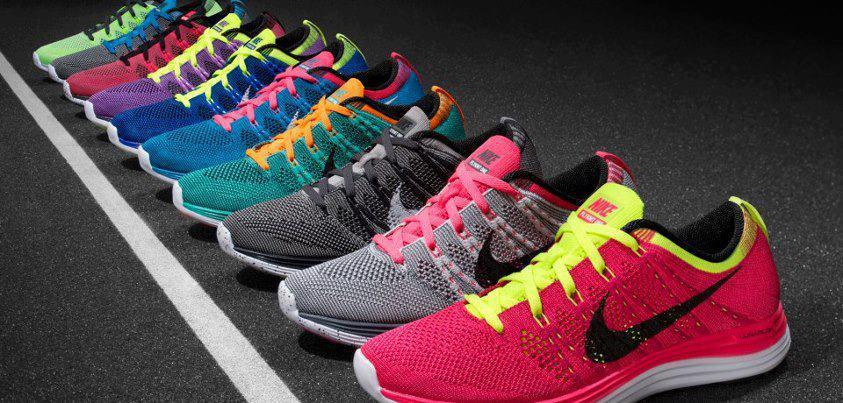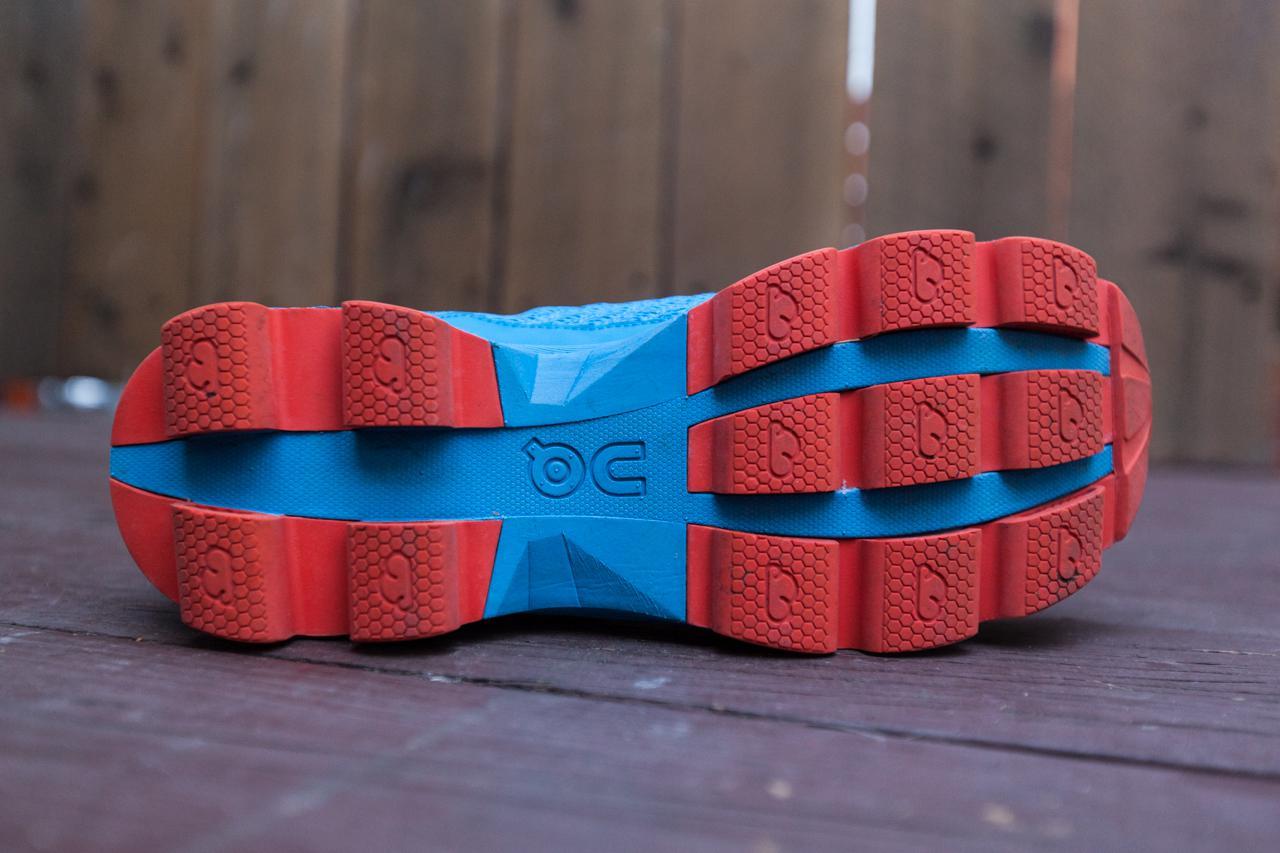The first image is the image on the left, the second image is the image on the right. Examine the images to the left and right. Is the description "The left image shows running shoes that are being worn on human feet" accurate? Answer yes or no. No. The first image is the image on the left, the second image is the image on the right. For the images shown, is this caption "An image contains only one right-side-up blue sneaker with a sole that is at least partly white." true? Answer yes or no. No. 